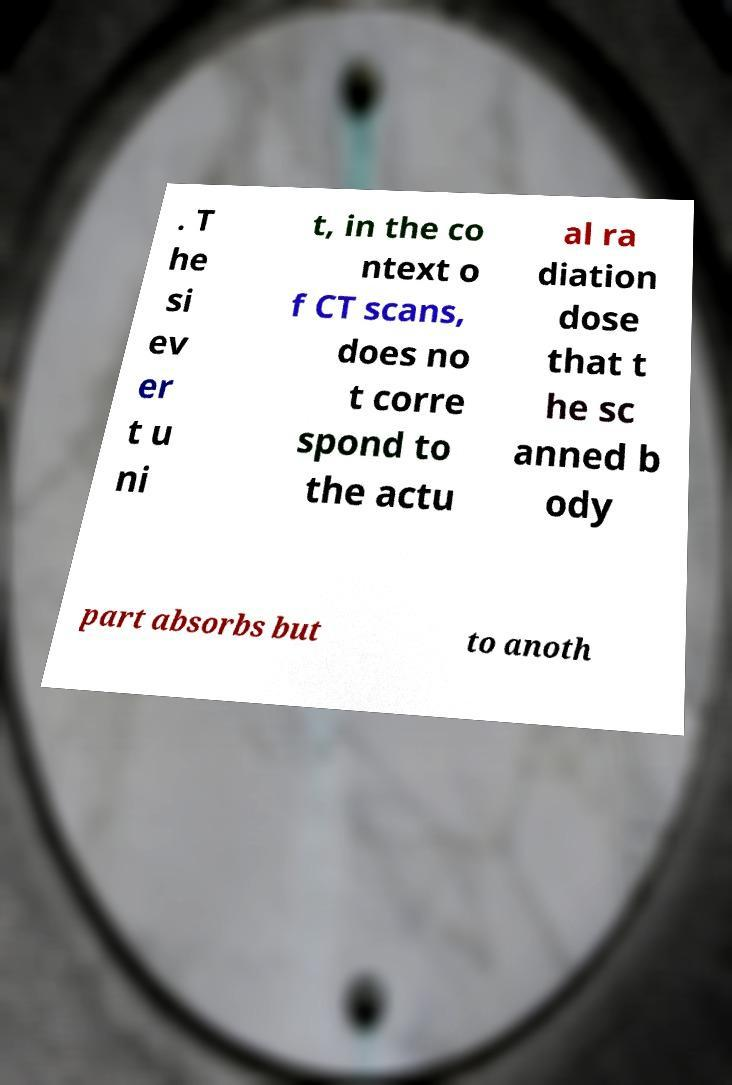Can you accurately transcribe the text from the provided image for me? . T he si ev er t u ni t, in the co ntext o f CT scans, does no t corre spond to the actu al ra diation dose that t he sc anned b ody part absorbs but to anoth 